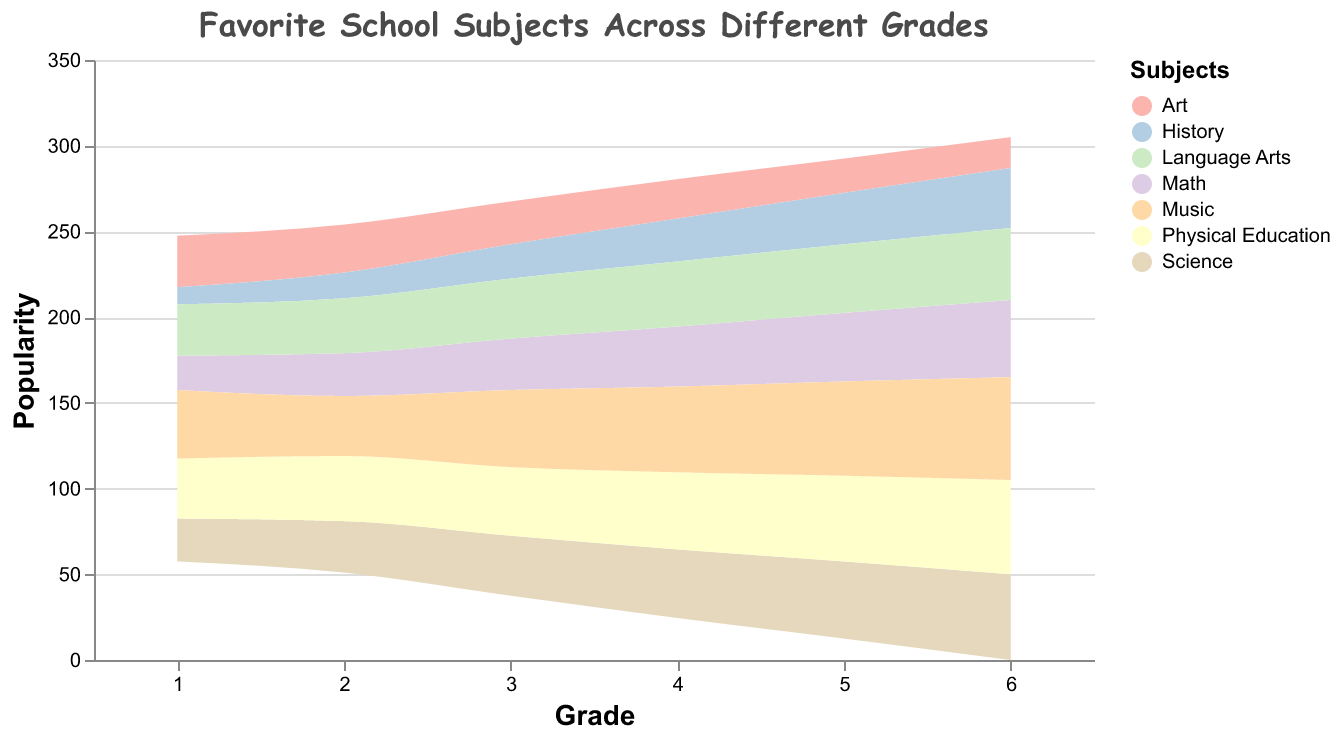What is the title of the figure? The title of the figure is displayed at the top, reading "Favorite School Subjects Across Different Grades."
Answer: Favorite School Subjects Across Different Grades Which subject is represented by the darkest color? By looking at the legend on the right which corresponds colors to subjects, it shows "Music" is denoted by the darkest color.
Answer: Music In which grade is the popularity of "Math" the highest? By examining the area associated with "Math" in different grades, we observe the area reaches its highest peak at Grade 6.
Answer: Grade 6 How does the popularity of "Art" change from Grade 1 to Grade 4? We follow the section of the stream graph corresponding to "Art," starting at a value of 30 in Grade 1, then decreasing gradually to 23 in Grade 4.
Answer: It decreases Compare the popularity of "Science" and "History" in Grade 3. Which is more popular? In Grade 3, the area for "Science" is higher than that for "History," indicating greater popularity.
Answer: Science What is the sum of the popularity values for "Physical Education" across all grades? Adding up the values of "Physical Education" from each grade (35, 38, 40, 45, 50, 55) gives a total of 263.
Answer: 263 By how much did the popularity of "Language Arts" increase from Grade 1 to Grade 6? The value for "Language Arts" in Grade 1 is 30, and in Grade 6 it is 42. The increase is 42 - 30 = 12.
Answer: By 12 Which subject shows a steady increase in popularity across all grades? By observing each subject, "Music" shows a continuous increase in popularity from Grade 1 through Grade 6.
Answer: Music Between Grades 2 and 4, which subject had the smallest change in popularity? Calculating the changes: Math (10), Science (10), Art (5), History (10), Physical Education (7), Music (15), Language Arts (6). "Art" had the smallest change (3 units).
Answer: Art In Grade 5, what is the combined popularity of "Math," "Science," and "Art"? The popularity values for Grade 5 are Math (40), Science (45), and Art (20). Adding them gives 40 + 45 + 20 = 105.
Answer: 105 